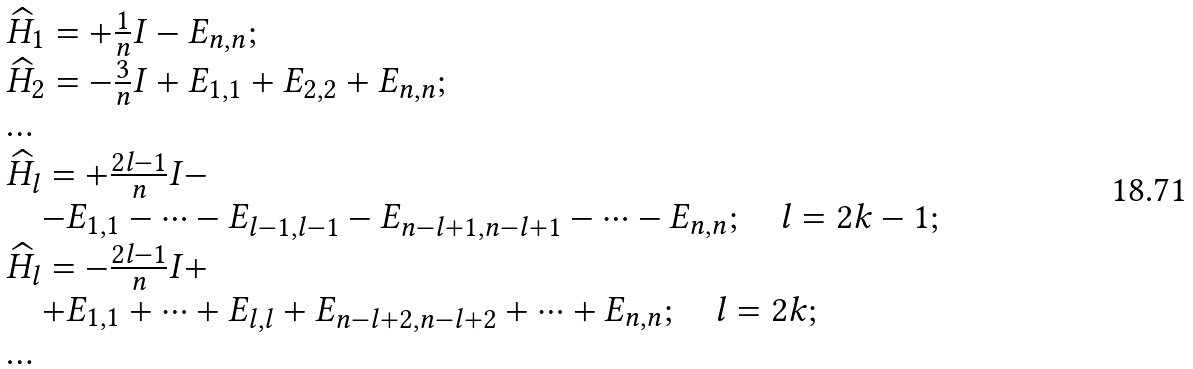Convert formula to latex. <formula><loc_0><loc_0><loc_500><loc_500>\begin{array} { l } \widehat { H } _ { 1 } = + \frac { 1 } { n } I - E _ { n , n } ; \\ \widehat { H } _ { 2 } = - \frac { 3 } { n } I + E _ { 1 , 1 } + E _ { 2 , 2 } + E _ { n , n } ; \\ \dots \\ \widehat { H } _ { l } = + \frac { 2 l - 1 } { n } I - \\ \quad - E _ { 1 , 1 } - \dots - E _ { l - 1 , l - 1 } - E _ { n - l + 1 , n - l + 1 } - \dots - E _ { n , n } ; \quad l = 2 k - 1 ; \\ \widehat { H } _ { l } = - \frac { 2 l - 1 } { n } I + \\ \quad + E _ { 1 , 1 } + \dots + E _ { l , l } + E _ { n - l + 2 , n - l + 2 } + \dots + E _ { n , n } ; \quad l = 2 k ; \\ \dots \end{array}</formula> 